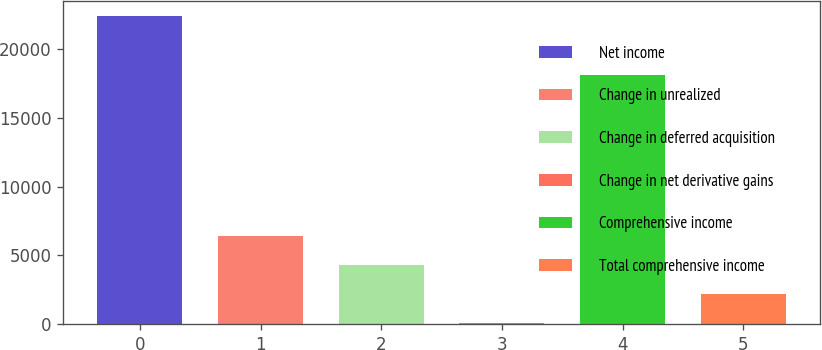Convert chart. <chart><loc_0><loc_0><loc_500><loc_500><bar_chart><fcel>Net income<fcel>Change in unrealized<fcel>Change in deferred acquisition<fcel>Change in net derivative gains<fcel>Comprehensive income<fcel>Total comprehensive income<nl><fcel>22394.8<fcel>6434.7<fcel>4306.8<fcel>51<fcel>18139<fcel>2178.9<nl></chart> 